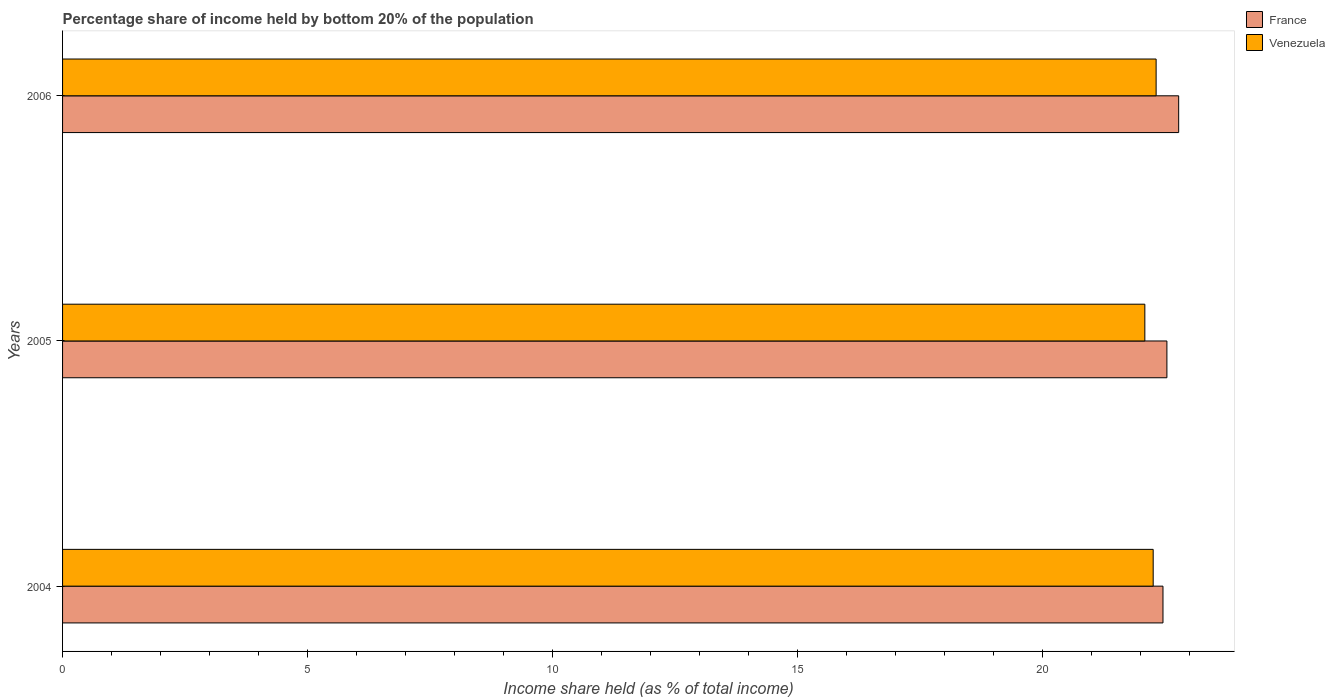How many different coloured bars are there?
Give a very brief answer. 2. Are the number of bars on each tick of the Y-axis equal?
Your response must be concise. Yes. How many bars are there on the 1st tick from the bottom?
Offer a terse response. 2. What is the label of the 2nd group of bars from the top?
Give a very brief answer. 2005. What is the share of income held by bottom 20% of the population in France in 2006?
Your answer should be compact. 22.77. Across all years, what is the maximum share of income held by bottom 20% of the population in Venezuela?
Your answer should be very brief. 22.31. Across all years, what is the minimum share of income held by bottom 20% of the population in France?
Provide a short and direct response. 22.45. In which year was the share of income held by bottom 20% of the population in Venezuela maximum?
Your answer should be compact. 2006. What is the total share of income held by bottom 20% of the population in France in the graph?
Your answer should be very brief. 67.75. What is the difference between the share of income held by bottom 20% of the population in France in 2004 and that in 2006?
Ensure brevity in your answer.  -0.32. What is the difference between the share of income held by bottom 20% of the population in Venezuela in 2004 and the share of income held by bottom 20% of the population in France in 2006?
Ensure brevity in your answer.  -0.52. What is the average share of income held by bottom 20% of the population in Venezuela per year?
Make the answer very short. 22.21. In the year 2005, what is the difference between the share of income held by bottom 20% of the population in Venezuela and share of income held by bottom 20% of the population in France?
Offer a very short reply. -0.45. What is the ratio of the share of income held by bottom 20% of the population in France in 2004 to that in 2005?
Offer a terse response. 1. Is the share of income held by bottom 20% of the population in France in 2005 less than that in 2006?
Provide a short and direct response. Yes. Is the difference between the share of income held by bottom 20% of the population in Venezuela in 2004 and 2005 greater than the difference between the share of income held by bottom 20% of the population in France in 2004 and 2005?
Provide a succinct answer. Yes. What is the difference between the highest and the second highest share of income held by bottom 20% of the population in France?
Your answer should be compact. 0.24. What is the difference between the highest and the lowest share of income held by bottom 20% of the population in France?
Keep it short and to the point. 0.32. In how many years, is the share of income held by bottom 20% of the population in France greater than the average share of income held by bottom 20% of the population in France taken over all years?
Offer a very short reply. 1. Is the sum of the share of income held by bottom 20% of the population in France in 2004 and 2005 greater than the maximum share of income held by bottom 20% of the population in Venezuela across all years?
Provide a short and direct response. Yes. What does the 1st bar from the bottom in 2004 represents?
Provide a short and direct response. France. How many bars are there?
Your response must be concise. 6. What is the difference between two consecutive major ticks on the X-axis?
Your response must be concise. 5. Does the graph contain any zero values?
Your response must be concise. No. Where does the legend appear in the graph?
Provide a succinct answer. Top right. How many legend labels are there?
Give a very brief answer. 2. How are the legend labels stacked?
Provide a short and direct response. Vertical. What is the title of the graph?
Give a very brief answer. Percentage share of income held by bottom 20% of the population. What is the label or title of the X-axis?
Ensure brevity in your answer.  Income share held (as % of total income). What is the Income share held (as % of total income) of France in 2004?
Your response must be concise. 22.45. What is the Income share held (as % of total income) in Venezuela in 2004?
Offer a very short reply. 22.25. What is the Income share held (as % of total income) in France in 2005?
Offer a terse response. 22.53. What is the Income share held (as % of total income) in Venezuela in 2005?
Your answer should be very brief. 22.08. What is the Income share held (as % of total income) in France in 2006?
Offer a terse response. 22.77. What is the Income share held (as % of total income) of Venezuela in 2006?
Ensure brevity in your answer.  22.31. Across all years, what is the maximum Income share held (as % of total income) in France?
Ensure brevity in your answer.  22.77. Across all years, what is the maximum Income share held (as % of total income) in Venezuela?
Ensure brevity in your answer.  22.31. Across all years, what is the minimum Income share held (as % of total income) of France?
Your response must be concise. 22.45. Across all years, what is the minimum Income share held (as % of total income) of Venezuela?
Offer a terse response. 22.08. What is the total Income share held (as % of total income) of France in the graph?
Provide a short and direct response. 67.75. What is the total Income share held (as % of total income) of Venezuela in the graph?
Your answer should be very brief. 66.64. What is the difference between the Income share held (as % of total income) of France in 2004 and that in 2005?
Provide a short and direct response. -0.08. What is the difference between the Income share held (as % of total income) in Venezuela in 2004 and that in 2005?
Offer a very short reply. 0.17. What is the difference between the Income share held (as % of total income) of France in 2004 and that in 2006?
Ensure brevity in your answer.  -0.32. What is the difference between the Income share held (as % of total income) in Venezuela in 2004 and that in 2006?
Offer a terse response. -0.06. What is the difference between the Income share held (as % of total income) of France in 2005 and that in 2006?
Your response must be concise. -0.24. What is the difference between the Income share held (as % of total income) of Venezuela in 2005 and that in 2006?
Your answer should be very brief. -0.23. What is the difference between the Income share held (as % of total income) of France in 2004 and the Income share held (as % of total income) of Venezuela in 2005?
Provide a succinct answer. 0.37. What is the difference between the Income share held (as % of total income) of France in 2004 and the Income share held (as % of total income) of Venezuela in 2006?
Give a very brief answer. 0.14. What is the difference between the Income share held (as % of total income) in France in 2005 and the Income share held (as % of total income) in Venezuela in 2006?
Keep it short and to the point. 0.22. What is the average Income share held (as % of total income) in France per year?
Your answer should be very brief. 22.58. What is the average Income share held (as % of total income) in Venezuela per year?
Provide a short and direct response. 22.21. In the year 2004, what is the difference between the Income share held (as % of total income) of France and Income share held (as % of total income) of Venezuela?
Keep it short and to the point. 0.2. In the year 2005, what is the difference between the Income share held (as % of total income) of France and Income share held (as % of total income) of Venezuela?
Your answer should be compact. 0.45. In the year 2006, what is the difference between the Income share held (as % of total income) of France and Income share held (as % of total income) of Venezuela?
Offer a very short reply. 0.46. What is the ratio of the Income share held (as % of total income) in France in 2004 to that in 2005?
Keep it short and to the point. 1. What is the ratio of the Income share held (as % of total income) in Venezuela in 2004 to that in 2005?
Keep it short and to the point. 1.01. What is the ratio of the Income share held (as % of total income) in France in 2004 to that in 2006?
Give a very brief answer. 0.99. What is the ratio of the Income share held (as % of total income) in Venezuela in 2004 to that in 2006?
Your answer should be very brief. 1. What is the difference between the highest and the second highest Income share held (as % of total income) of France?
Ensure brevity in your answer.  0.24. What is the difference between the highest and the lowest Income share held (as % of total income) of France?
Ensure brevity in your answer.  0.32. What is the difference between the highest and the lowest Income share held (as % of total income) of Venezuela?
Offer a terse response. 0.23. 